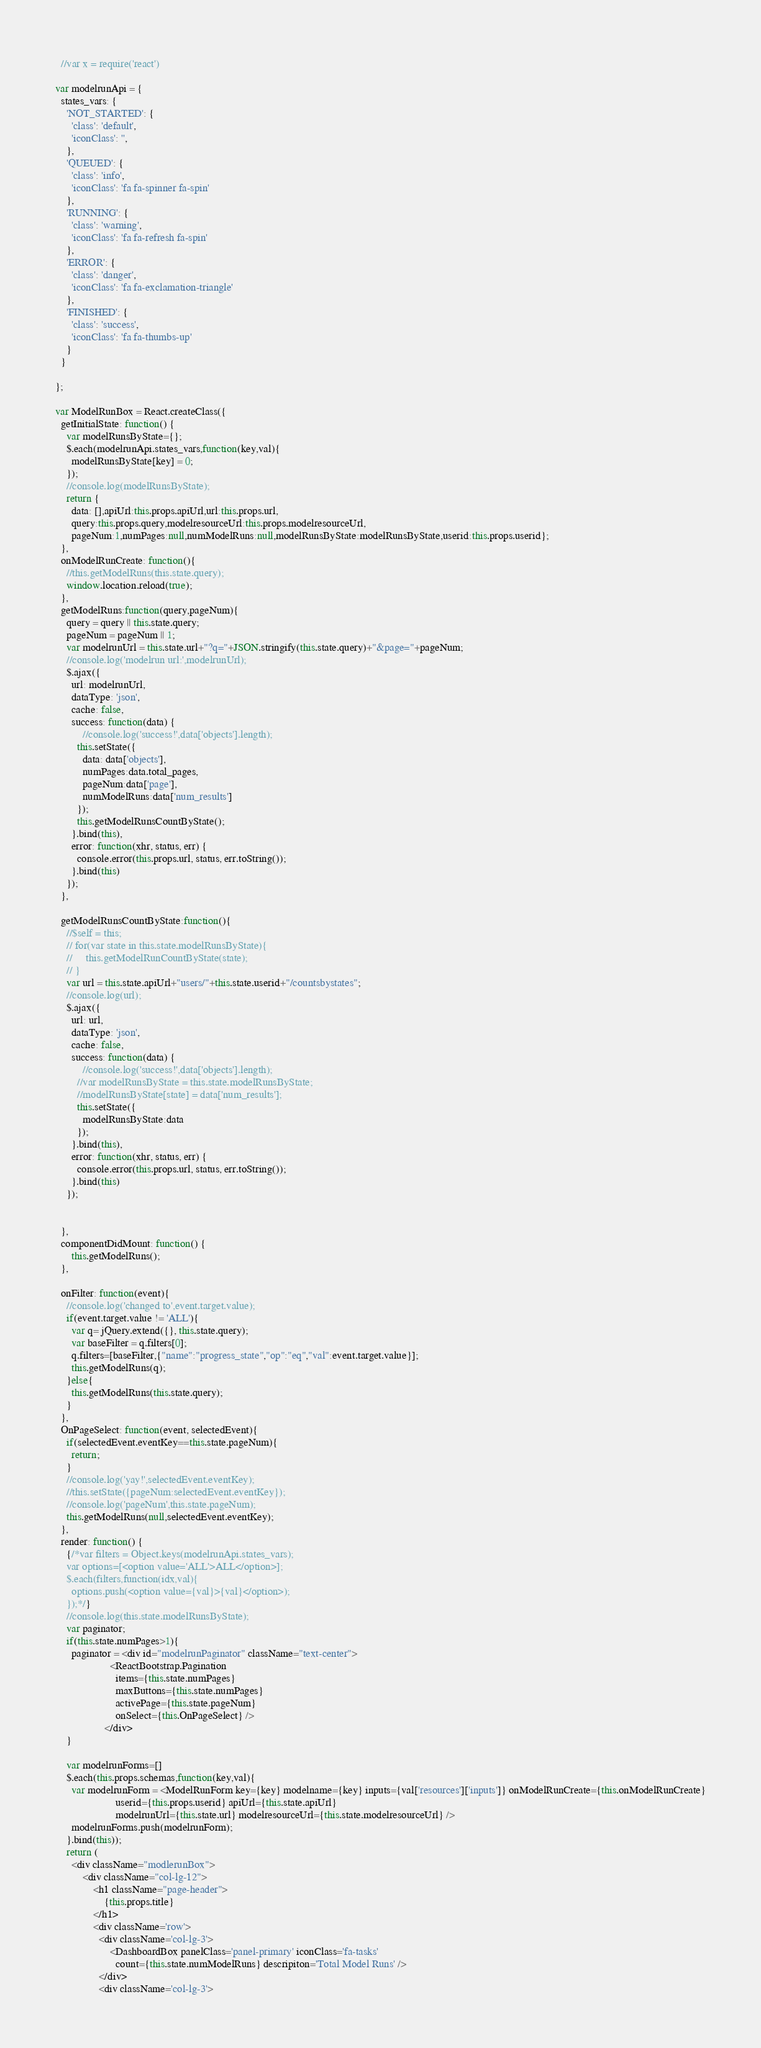Convert code to text. <code><loc_0><loc_0><loc_500><loc_500><_JavaScript_>  //var x = require('react')

var modelrunApi = {
  states_vars: {
    'NOT_STARTED': {
      'class': 'default',
      'iconClass': '',
    },
    'QUEUED': {
      'class': 'info',
      'iconClass': 'fa fa-spinner fa-spin'
    },
    'RUNNING': {
      'class': 'warning',
      'iconClass': 'fa fa-refresh fa-spin'
    },
    'ERROR': {
      'class': 'danger',
      'iconClass': 'fa fa-exclamation-triangle'
    },
    'FINISHED': {
      'class': 'success',
      'iconClass': 'fa fa-thumbs-up'
    }
  }

};

var ModelRunBox = React.createClass({
  getInitialState: function() {
    var modelRunsByState={};
    $.each(modelrunApi.states_vars,function(key,val){
      modelRunsByState[key] = 0;
    });
    //console.log(modelRunsByState);
    return {
      data: [],apiUrl:this.props.apiUrl,url:this.props.url,
      query:this.props.query,modelresourceUrl:this.props.modelresourceUrl,
      pageNum:1,numPages:null,numModelRuns:null,modelRunsByState:modelRunsByState,userid:this.props.userid};
  },
  onModelRunCreate: function(){
    //this.getModelRuns(this.state.query);
    window.location.reload(true);
  },
  getModelRuns:function(query,pageNum){
    query = query || this.state.query;
    pageNum = pageNum || 1;
    var modelrunUrl = this.state.url+"?q="+JSON.stringify(this.state.query)+"&page="+pageNum;
    //console.log('modelrun url:',modelrunUrl);
    $.ajax({
      url: modelrunUrl,
      dataType: 'json',
      cache: false,
      success: function(data) {
          //console.log('success!',data['objects'].length);
        this.setState({
          data: data['objects'],
          numPages:data.total_pages,
          pageNum:data['page'],
          numModelRuns:data['num_results']
        });
        this.getModelRunsCountByState();
      }.bind(this),
      error: function(xhr, status, err) {
        console.error(this.props.url, status, err.toString());
      }.bind(this)
    });
  },

  getModelRunsCountByState:function(){
    //$self = this;
    // for(var state in this.state.modelRunsByState){
    //     this.getModelRunCountByState(state);
    // }
    var url = this.state.apiUrl+"users/"+this.state.userid+"/countsbystates";
    //console.log(url);
    $.ajax({
      url: url,
      dataType: 'json',
      cache: false,
      success: function(data) {
          //console.log('success!',data['objects'].length);
        //var modelRunsByState = this.state.modelRunsByState;
        //modelRunsByState[state] = data['num_results'];
        this.setState({
          modelRunsByState:data
        });
      }.bind(this),
      error: function(xhr, status, err) {
        console.error(this.props.url, status, err.toString());
      }.bind(this)
    });


  },
  componentDidMount: function() {
      this.getModelRuns();
  },

  onFilter: function(event){
    //console.log('changed to',event.target.value);
    if(event.target.value != 'ALL'){
      var q= jQuery.extend({}, this.state.query);
      var baseFilter = q.filters[0];
      q.filters=[baseFilter,{"name":"progress_state","op":"eq","val":event.target.value}];
      this.getModelRuns(q);
    }else{
      this.getModelRuns(this.state.query);
    }
  },
  OnPageSelect: function(event, selectedEvent){
    if(selectedEvent.eventKey==this.state.pageNum){
      return;
    }
    //console.log('yay!',selectedEvent.eventKey);
    //this.setState({pageNum:selectedEvent.eventKey});
    //console.log('pageNum',this.state.pageNum);
    this.getModelRuns(null,selectedEvent.eventKey);
  },
  render: function() {
    {/*var filters = Object.keys(modelrunApi.states_vars);
    var options=[<option value='ALL'>ALL</option>];
    $.each(filters,function(idx,val){
      options.push(<option value={val}>{val}</option>);
    });*/}
    //console.log(this.state.modelRunsByState);
    var paginator;
    if(this.state.numPages>1){
      paginator = <div id="modelrunPaginator" className="text-center">
                    <ReactBootstrap.Pagination
                      items={this.state.numPages}
                      maxButtons={this.state.numPages}
                      activePage={this.state.pageNum}
                      onSelect={this.OnPageSelect} />
                  </div>
    }

    var modelrunForms=[]
    $.each(this.props.schemas,function(key,val){
      var modelrunForm = <ModelRunForm key={key} modelname={key} inputs={val['resources']['inputs']} onModelRunCreate={this.onModelRunCreate}
                      userid={this.props.userid} apiUrl={this.state.apiUrl}
                      modelrunUrl={this.state.url} modelresourceUrl={this.state.modelresourceUrl} />
      modelrunForms.push(modelrunForm);
    }.bind(this));
    return (
      <div className="modlerunBox">
          <div className="col-lg-12">
              <h1 className="page-header">
                  {this.props.title}
              </h1>
              <div className='row'>
                <div className='col-lg-3'>
                    <DashboardBox panelClass='panel-primary' iconClass='fa-tasks'
                      count={this.state.numModelRuns} descripiton='Total Model Runs' />
                </div>
                <div className='col-lg-3'></code> 